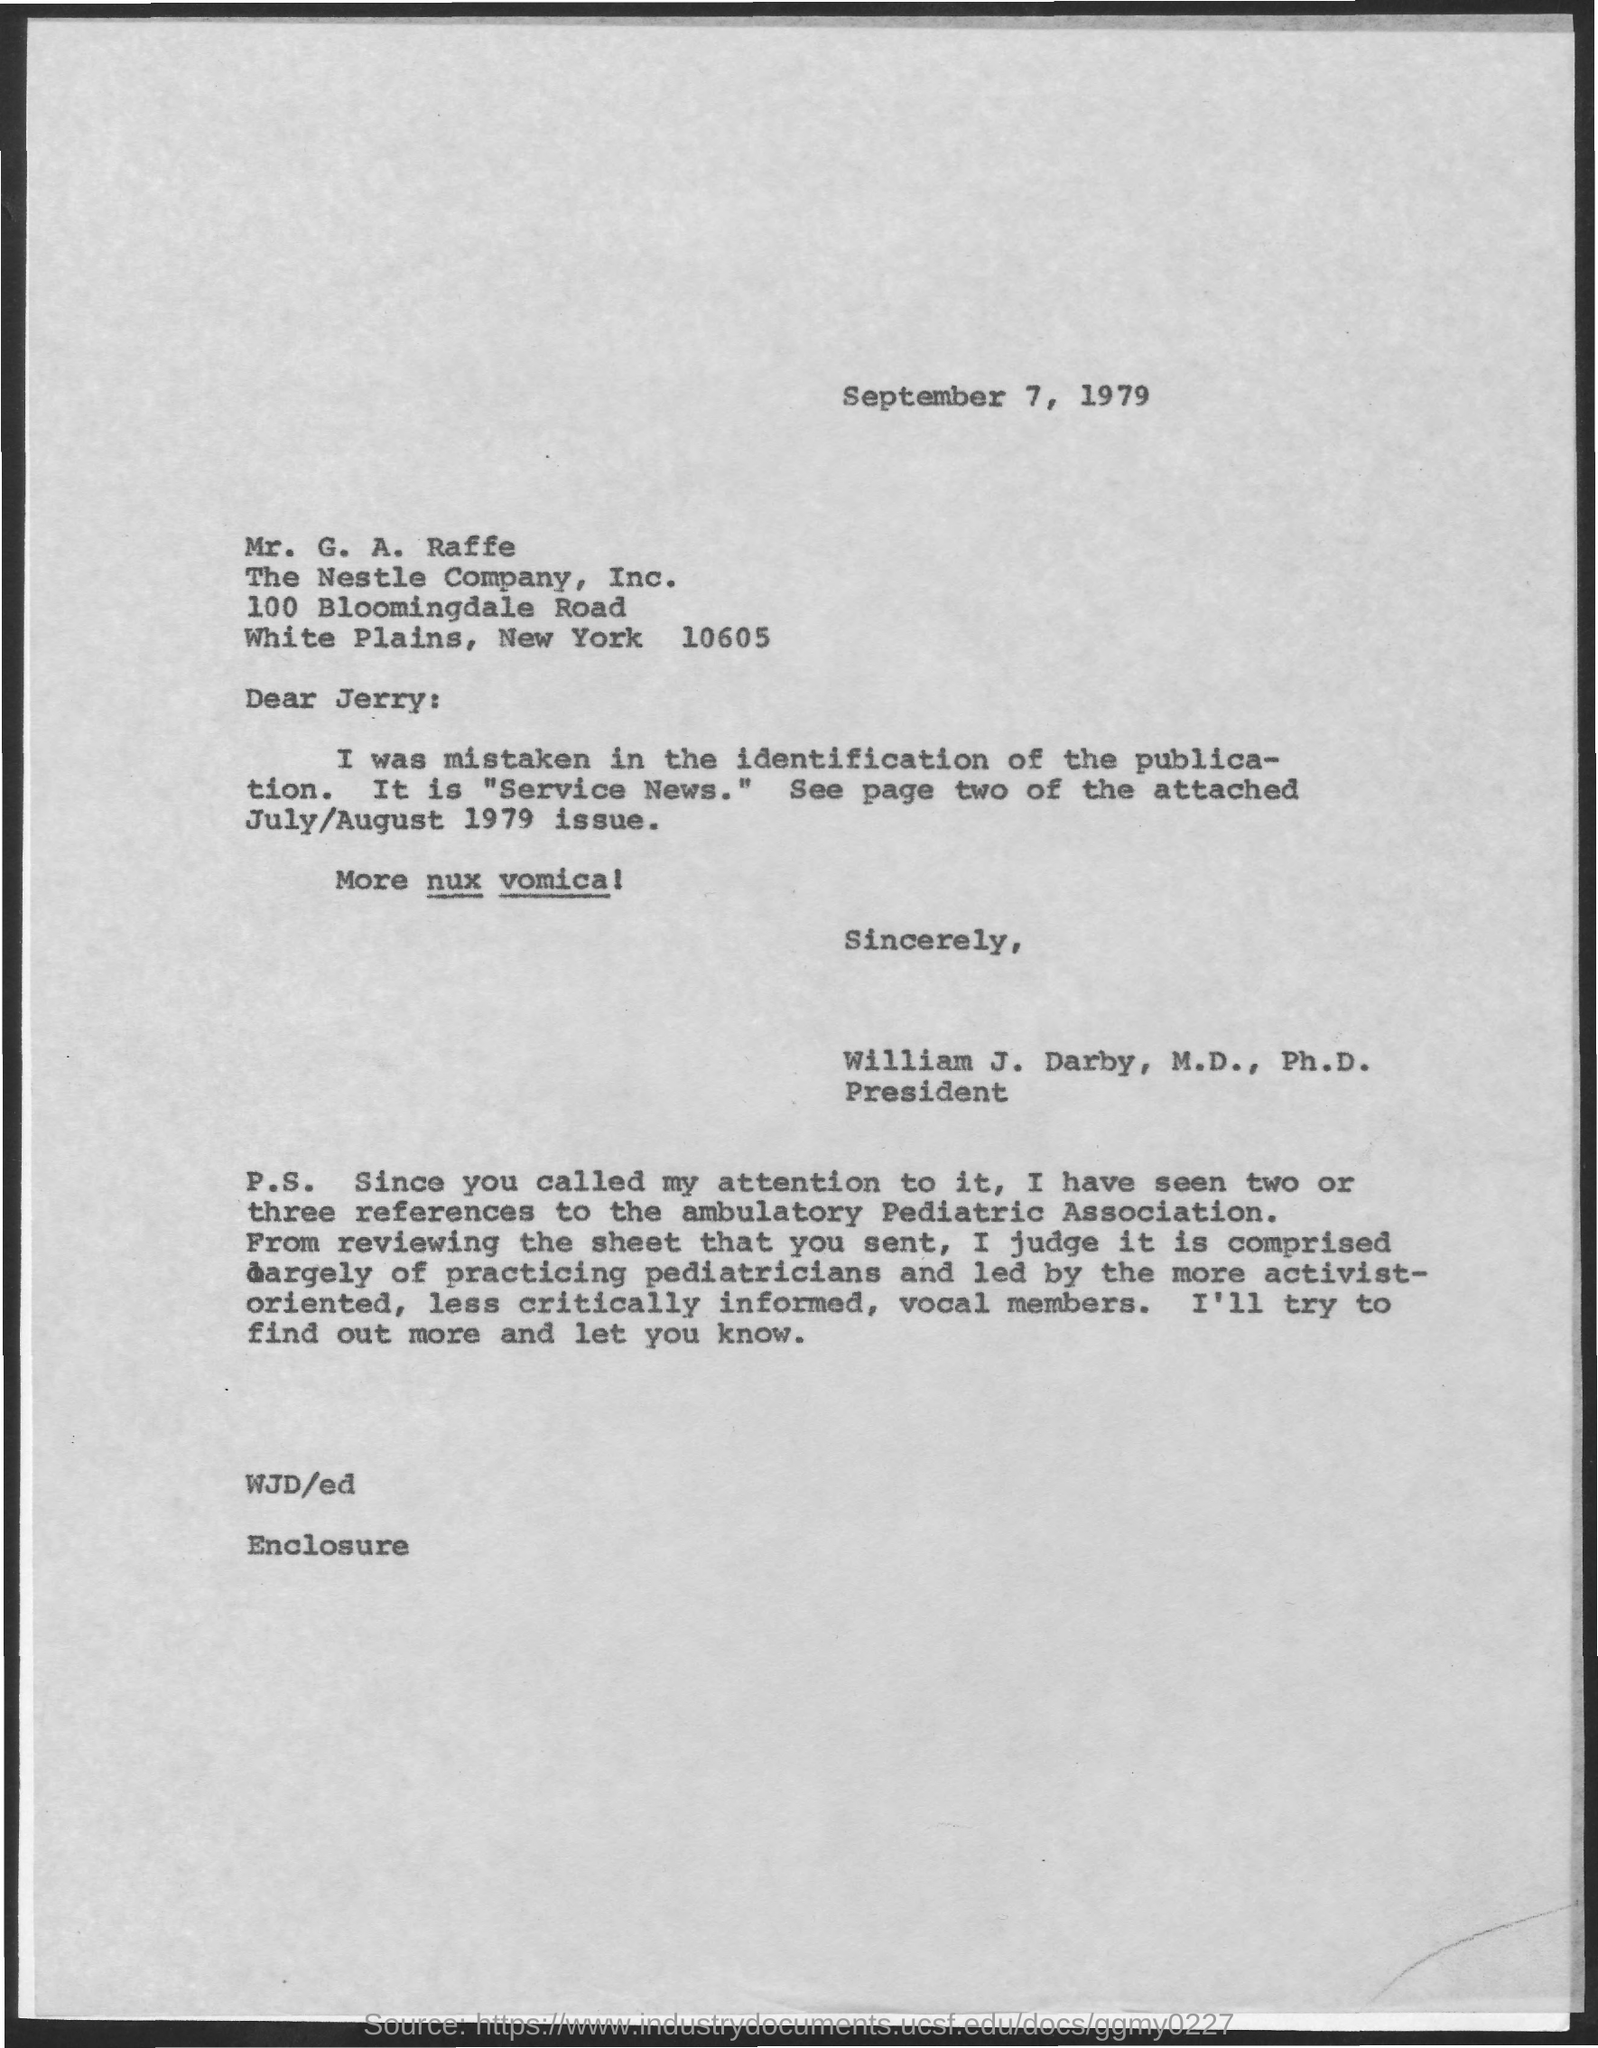To Whom is this letter addressed to?
Give a very brief answer. Jerry. 